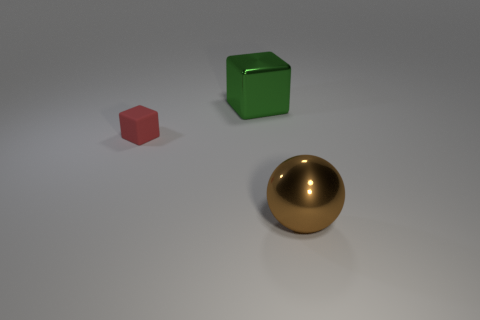Is the shape of the shiny thing behind the brown metallic ball the same as the object that is in front of the matte thing?
Give a very brief answer. No. What number of rubber things are behind the brown metal sphere?
Your response must be concise. 1. Are there any red objects made of the same material as the big block?
Your answer should be compact. No. There is a brown object that is the same size as the green metal object; what is it made of?
Give a very brief answer. Metal. Does the green thing have the same material as the tiny red object?
Keep it short and to the point. No. What number of things are big brown metallic objects or big purple shiny cubes?
Make the answer very short. 1. What shape is the object in front of the small cube?
Your response must be concise. Sphere. What is the color of the big ball that is made of the same material as the big green cube?
Provide a short and direct response. Brown. There is a tiny red object that is the same shape as the large green shiny thing; what is its material?
Provide a succinct answer. Rubber. What is the shape of the tiny red rubber thing?
Make the answer very short. Cube. 